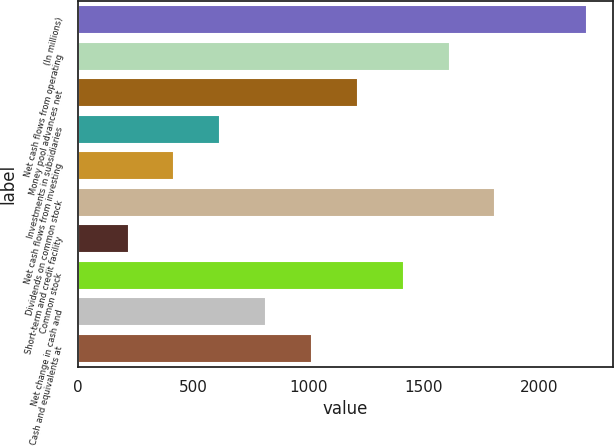Convert chart to OTSL. <chart><loc_0><loc_0><loc_500><loc_500><bar_chart><fcel>(In millions)<fcel>Net cash flows from operating<fcel>Money pool advances net<fcel>Investments in subsidiaries<fcel>Net cash flows from investing<fcel>Dividends on common stock<fcel>Short-term and credit facility<fcel>Common stock<fcel>Net change in cash and<fcel>Cash and equivalents at<nl><fcel>2206.6<fcel>1610.8<fcel>1213.6<fcel>617.8<fcel>419.2<fcel>1809.4<fcel>220.6<fcel>1412.2<fcel>816.4<fcel>1015<nl></chart> 